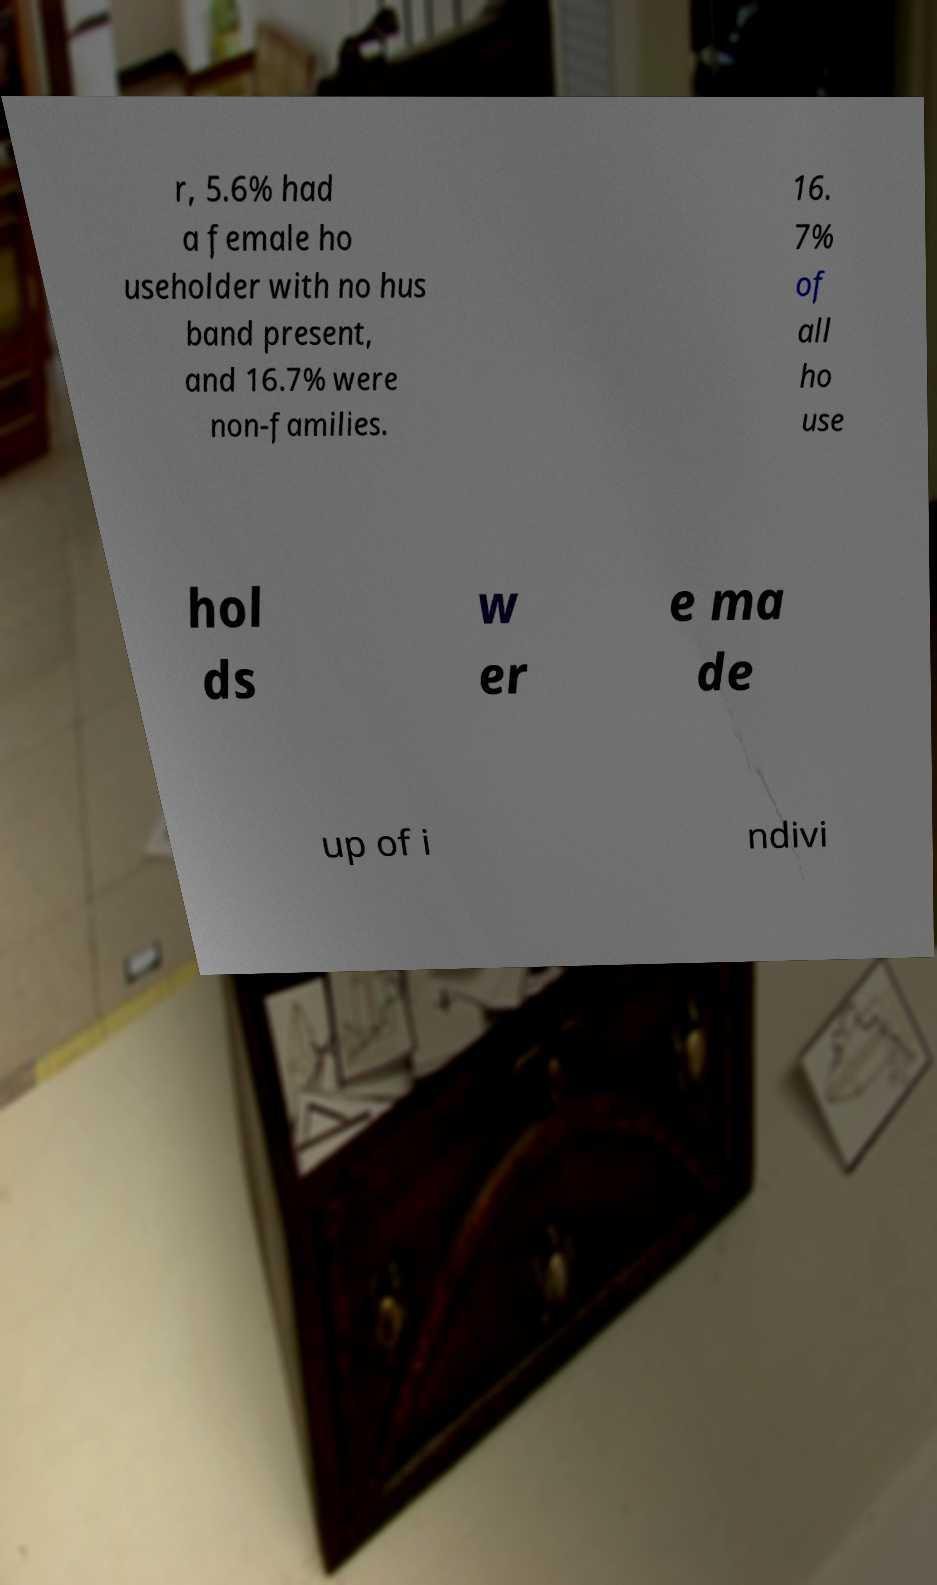Could you assist in decoding the text presented in this image and type it out clearly? r, 5.6% had a female ho useholder with no hus band present, and 16.7% were non-families. 16. 7% of all ho use hol ds w er e ma de up of i ndivi 